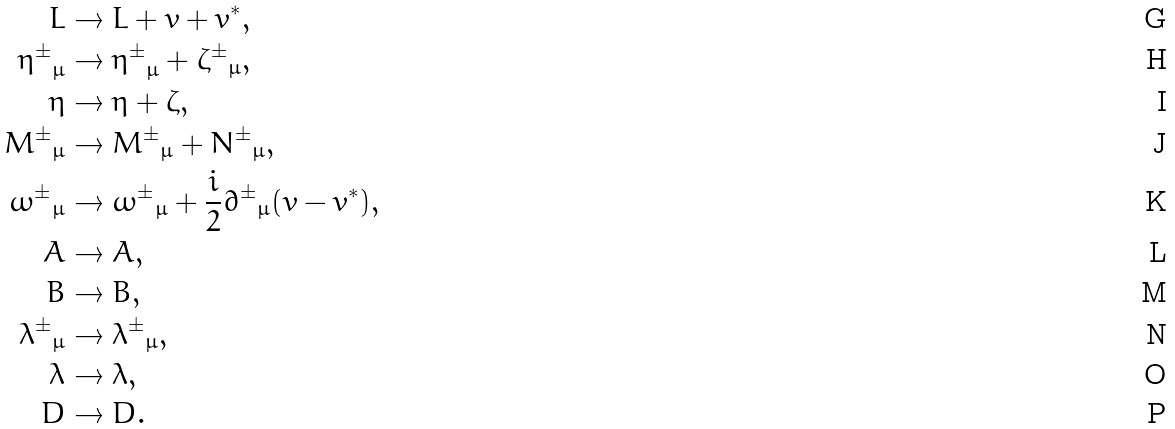Convert formula to latex. <formula><loc_0><loc_0><loc_500><loc_500>L & \rightarrow L + v + v ^ { * } , \\ { \eta ^ { \pm } } _ { \mu } & \rightarrow { \eta ^ { \pm } } _ { \mu } + { \zeta ^ { \pm } } _ { \mu } , \\ \eta & \rightarrow \eta + \zeta , \\ { M ^ { \pm } } _ { \mu } & \rightarrow { M ^ { \pm } } _ { \mu } + { N ^ { \pm } } _ { \mu } , \\ { \omega ^ { \pm } } _ { \mu } & \rightarrow { \omega ^ { \pm } } _ { \mu } + \frac { i } { 2 } { \partial ^ { \pm } } _ { \mu } ( v - v ^ { * } ) , \\ A & \rightarrow A , \\ B & \rightarrow B , \\ { \lambda ^ { \pm } } _ { \mu } & \rightarrow { \lambda ^ { \pm } } _ { \mu } , \\ \lambda & \rightarrow \lambda , \\ D & \rightarrow D .</formula> 